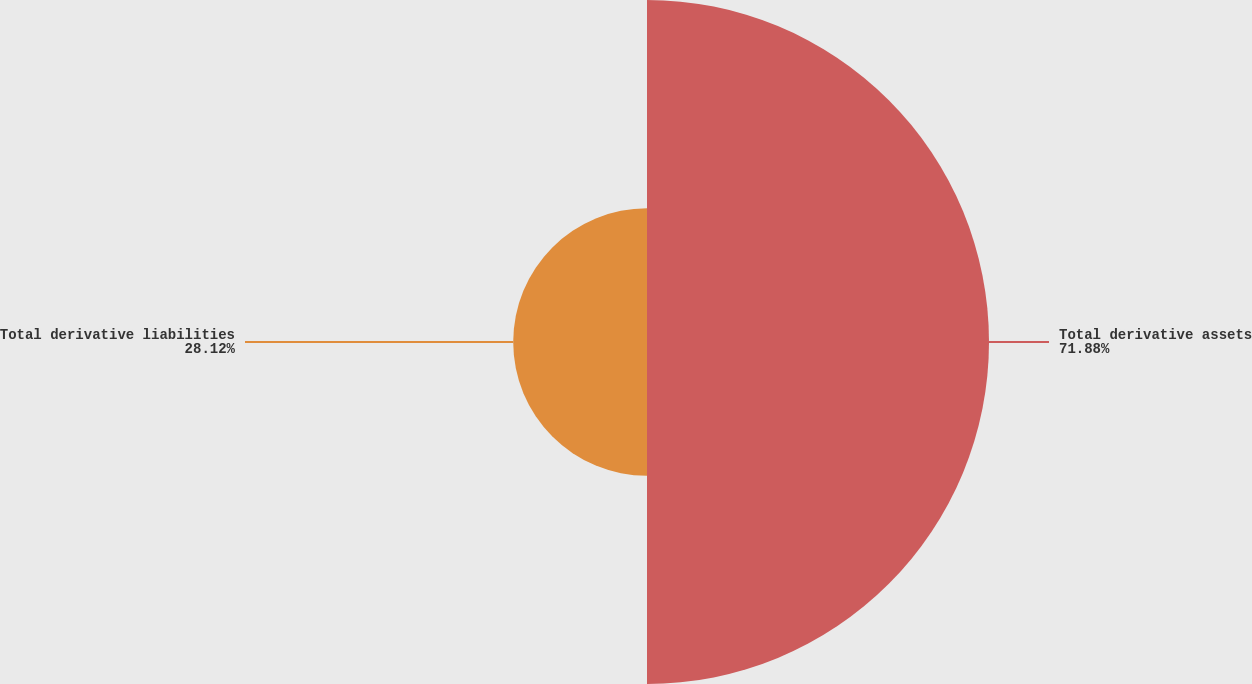<chart> <loc_0><loc_0><loc_500><loc_500><pie_chart><fcel>Total derivative assets<fcel>Total derivative liabilities<nl><fcel>71.88%<fcel>28.12%<nl></chart> 